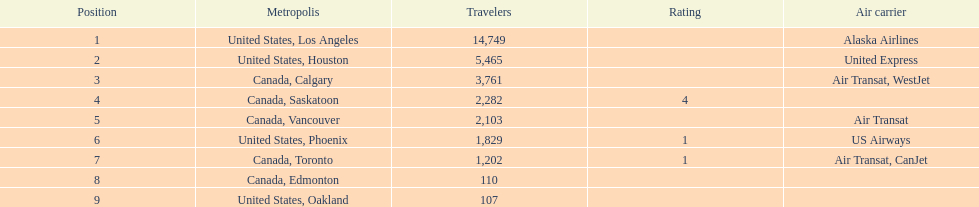What cities do the planes fly to? United States, Los Angeles, United States, Houston, Canada, Calgary, Canada, Saskatoon, Canada, Vancouver, United States, Phoenix, Canada, Toronto, Canada, Edmonton, United States, Oakland. How many people are flying to phoenix, arizona? 1,829. 